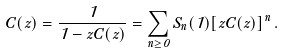Convert formula to latex. <formula><loc_0><loc_0><loc_500><loc_500>C ( z ) = \frac { 1 } { 1 - z C ( z ) } = \sum _ { n \geq 0 } S _ { n } ( 1 ) [ z C ( z ) ] ^ { n } \, .</formula> 